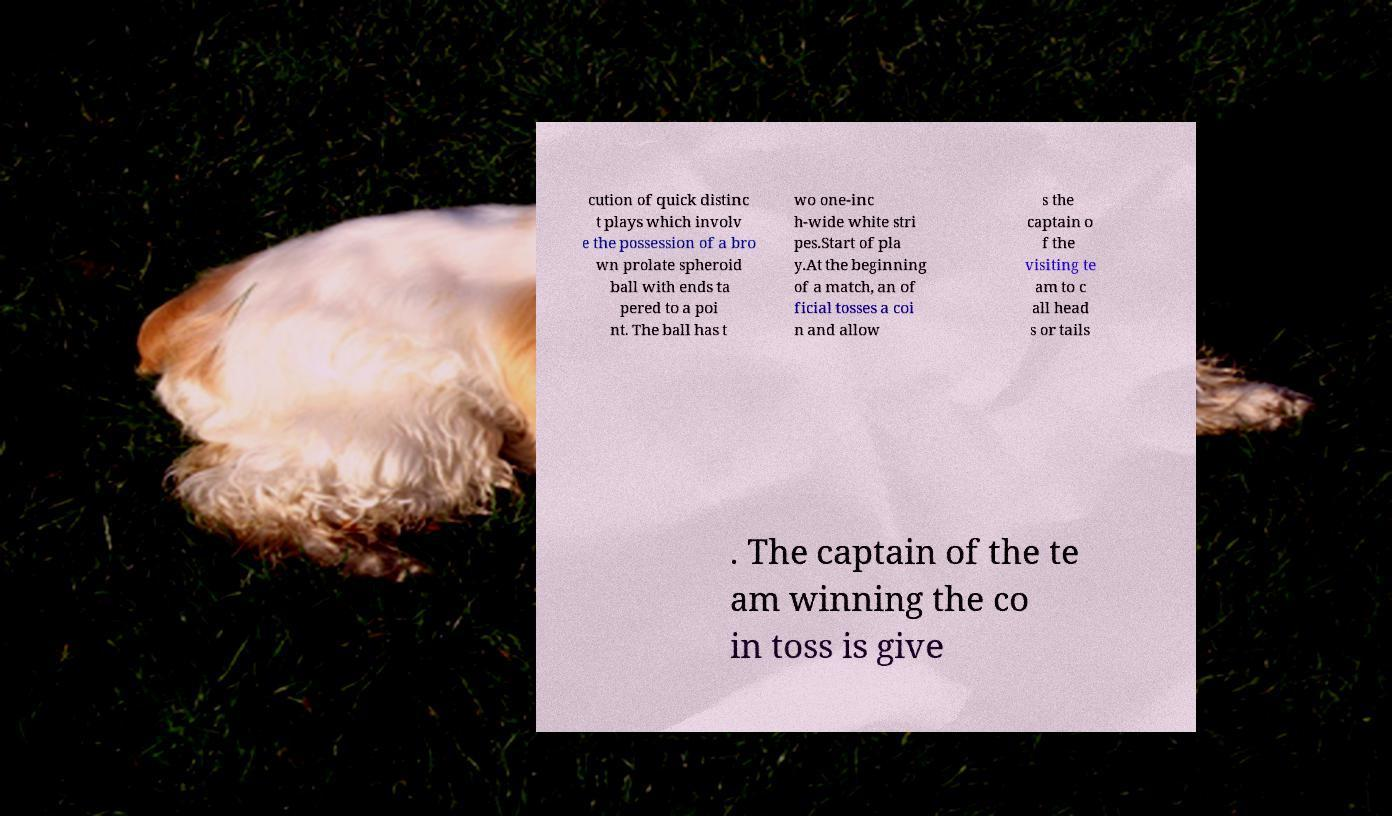Can you accurately transcribe the text from the provided image for me? cution of quick distinc t plays which involv e the possession of a bro wn prolate spheroid ball with ends ta pered to a poi nt. The ball has t wo one-inc h-wide white stri pes.Start of pla y.At the beginning of a match, an of ficial tosses a coi n and allow s the captain o f the visiting te am to c all head s or tails . The captain of the te am winning the co in toss is give 